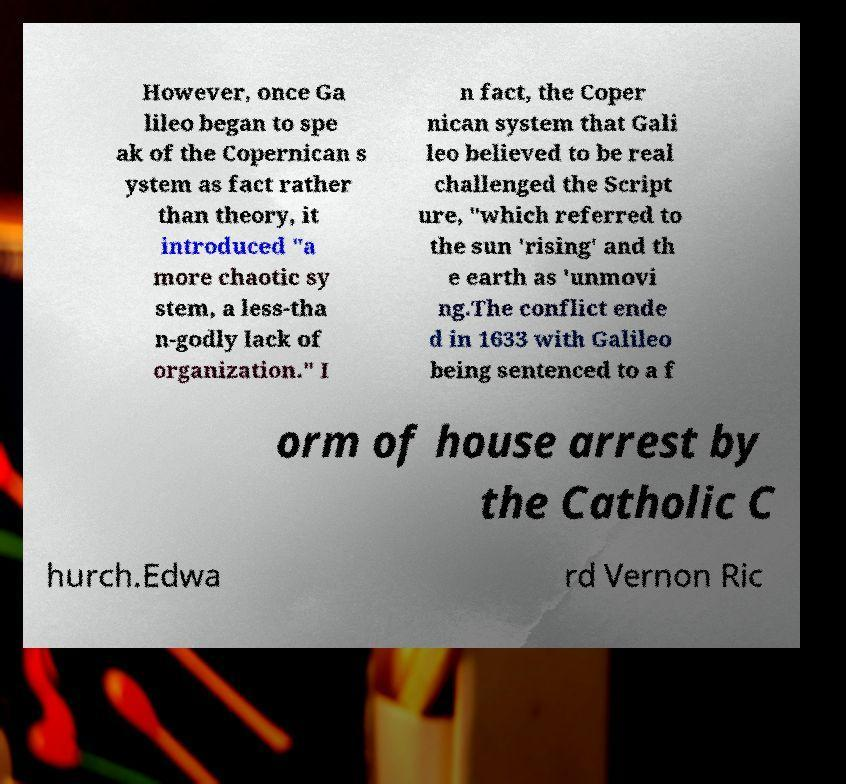I need the written content from this picture converted into text. Can you do that? However, once Ga lileo began to spe ak of the Copernican s ystem as fact rather than theory, it introduced "a more chaotic sy stem, a less-tha n-godly lack of organization." I n fact, the Coper nican system that Gali leo believed to be real challenged the Script ure, "which referred to the sun 'rising' and th e earth as 'unmovi ng.The conflict ende d in 1633 with Galileo being sentenced to a f orm of house arrest by the Catholic C hurch.Edwa rd Vernon Ric 